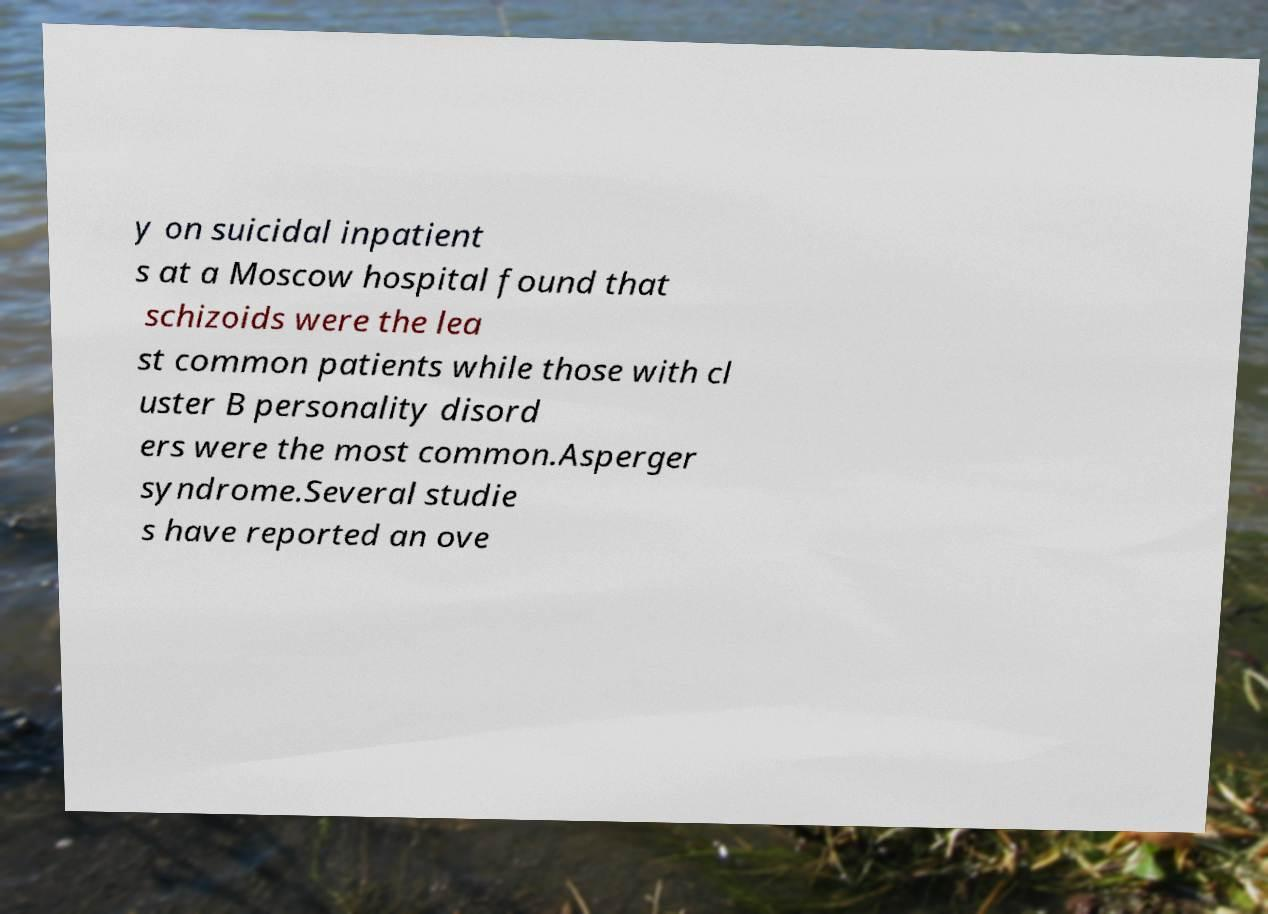For documentation purposes, I need the text within this image transcribed. Could you provide that? y on suicidal inpatient s at a Moscow hospital found that schizoids were the lea st common patients while those with cl uster B personality disord ers were the most common.Asperger syndrome.Several studie s have reported an ove 